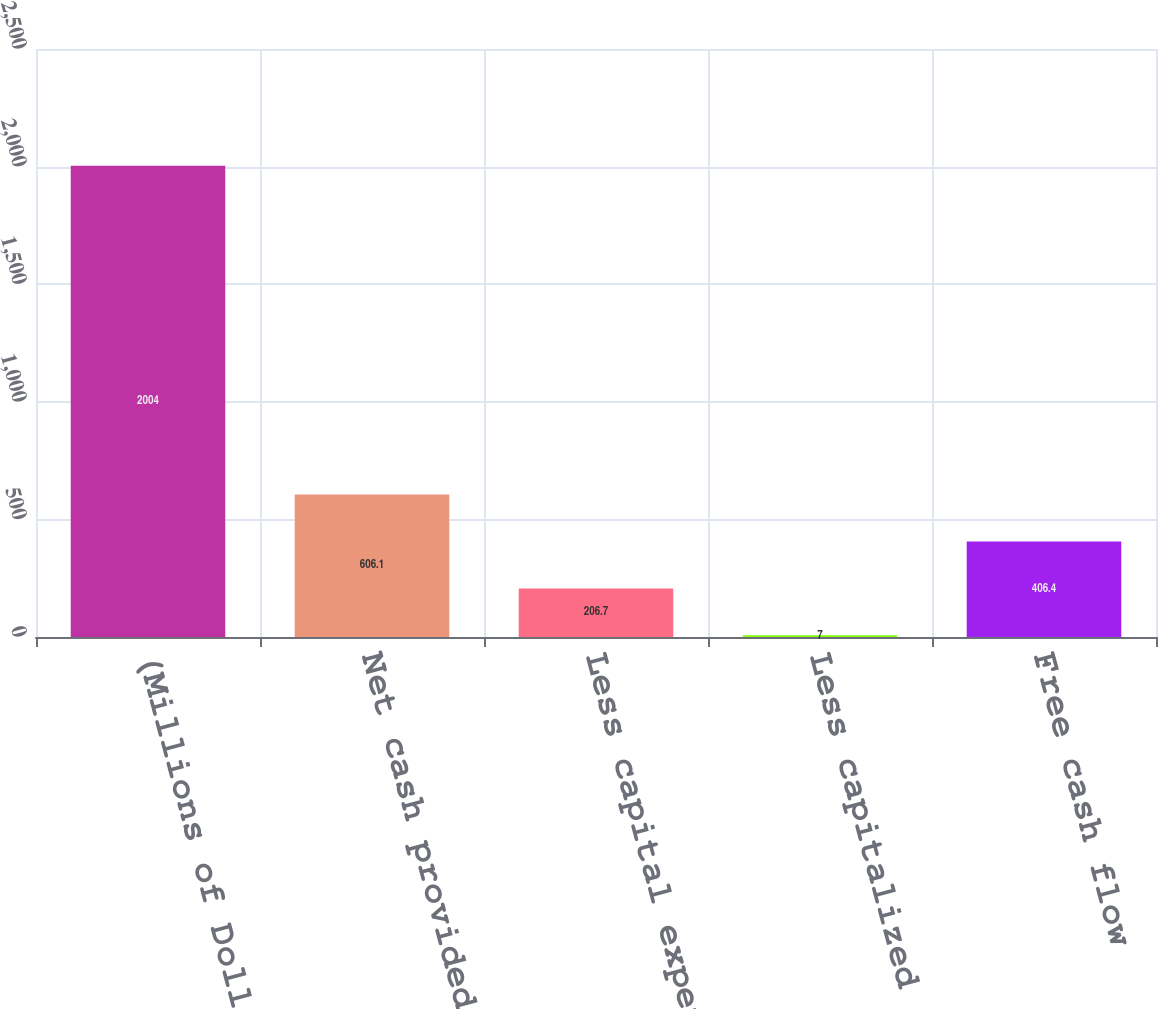Convert chart to OTSL. <chart><loc_0><loc_0><loc_500><loc_500><bar_chart><fcel>(Millions of Dollars)<fcel>Net cash provided by operating<fcel>Less capital expenditures<fcel>Less capitalized software<fcel>Free cash flow<nl><fcel>2004<fcel>606.1<fcel>206.7<fcel>7<fcel>406.4<nl></chart> 